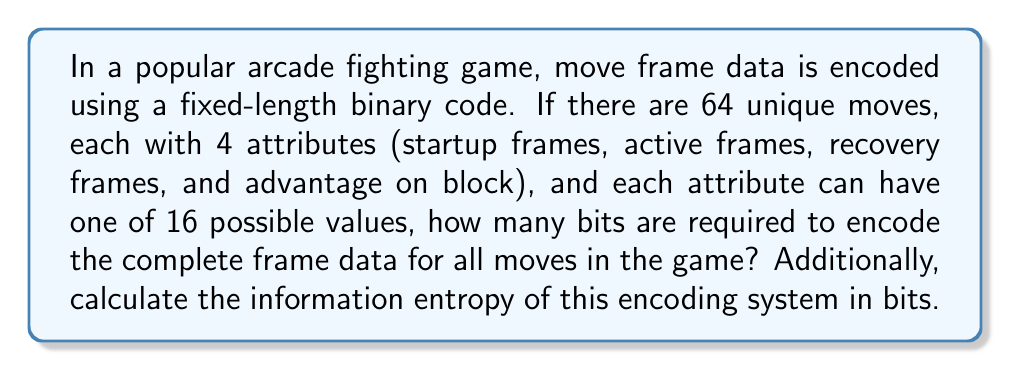Help me with this question. Let's break this down step-by-step:

1) First, we need to calculate the number of bits required to encode each attribute:
   - There are 16 possible values for each attribute
   - To encode 16 values, we need $\log_2(16) = 4$ bits

2) For each move, we have 4 attributes:
   - Total bits per move = 4 attributes × 4 bits = 16 bits

3) There are 64 unique moves in the game:
   - Total bits for all moves = 64 moves × 16 bits per move = 1024 bits

4) To calculate the information entropy, we need to consider the probability distribution of the encoding:
   - In this case, we have a fixed-length code, so all possible combinations are equally likely
   - The number of possible combinations is $2^{1024}$
   - The probability of each combination is $p = \frac{1}{2^{1024}}$

5) The entropy H is calculated using the formula:
   $$H = -\sum_{i=1}^{n} p_i \log_2(p_i)$$
   
   Where $n = 2^{1024}$ and all $p_i = \frac{1}{2^{1024}}$

6) Substituting these values:
   $$H = -2^{1024} \cdot \frac{1}{2^{1024}} \log_2(\frac{1}{2^{1024}})$$
   $$= -\log_2(\frac{1}{2^{1024}})$$
   $$= \log_2(2^{1024})$$
   $$= 1024 \text{ bits}$$

The entropy equals the number of bits in the encoding, which is expected for a fixed-length binary code where all combinations are equally likely.
Answer: 1024 bits are required to encode the complete frame data for all moves, and the information entropy of this encoding system is 1024 bits. 